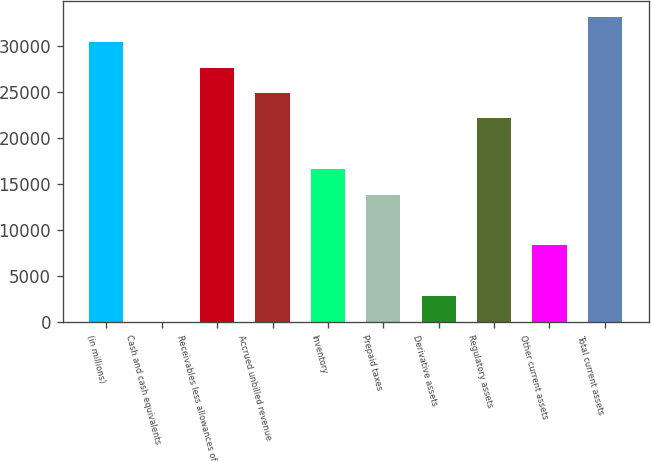Convert chart to OTSL. <chart><loc_0><loc_0><loc_500><loc_500><bar_chart><fcel>(in millions)<fcel>Cash and cash equivalents<fcel>Receivables less allowances of<fcel>Accrued unbilled revenue<fcel>Inventory<fcel>Prepaid taxes<fcel>Derivative assets<fcel>Regulatory assets<fcel>Other current assets<fcel>Total current assets<nl><fcel>30400.5<fcel>57<fcel>27642<fcel>24883.5<fcel>16608<fcel>13849.5<fcel>2815.5<fcel>22125<fcel>8332.5<fcel>33159<nl></chart> 